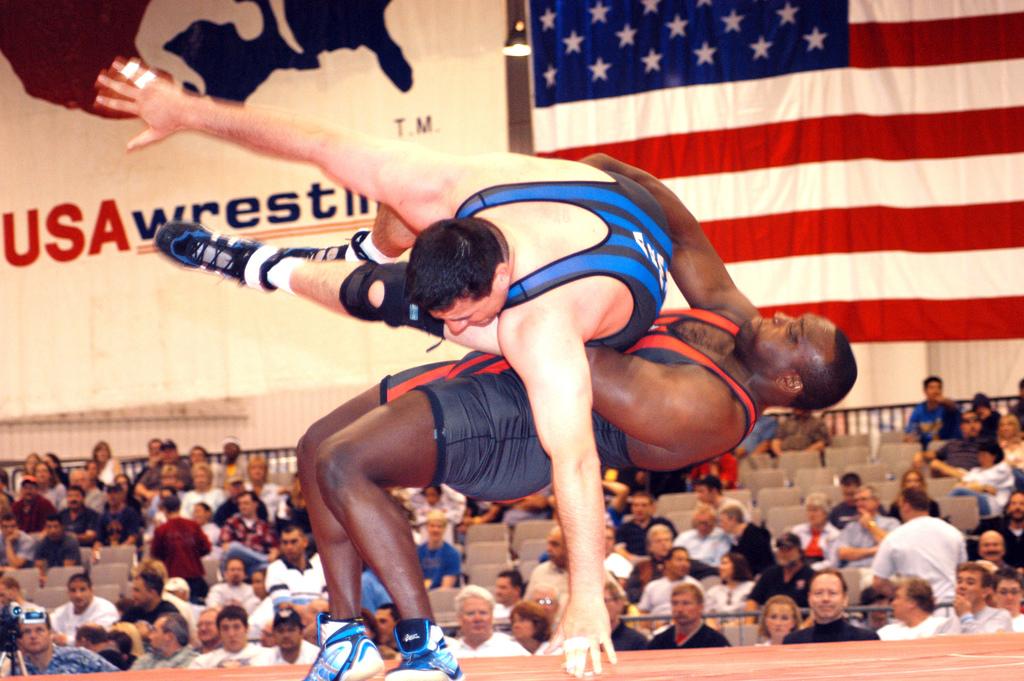What country are these men wrestling in?
Ensure brevity in your answer.  Usa. 